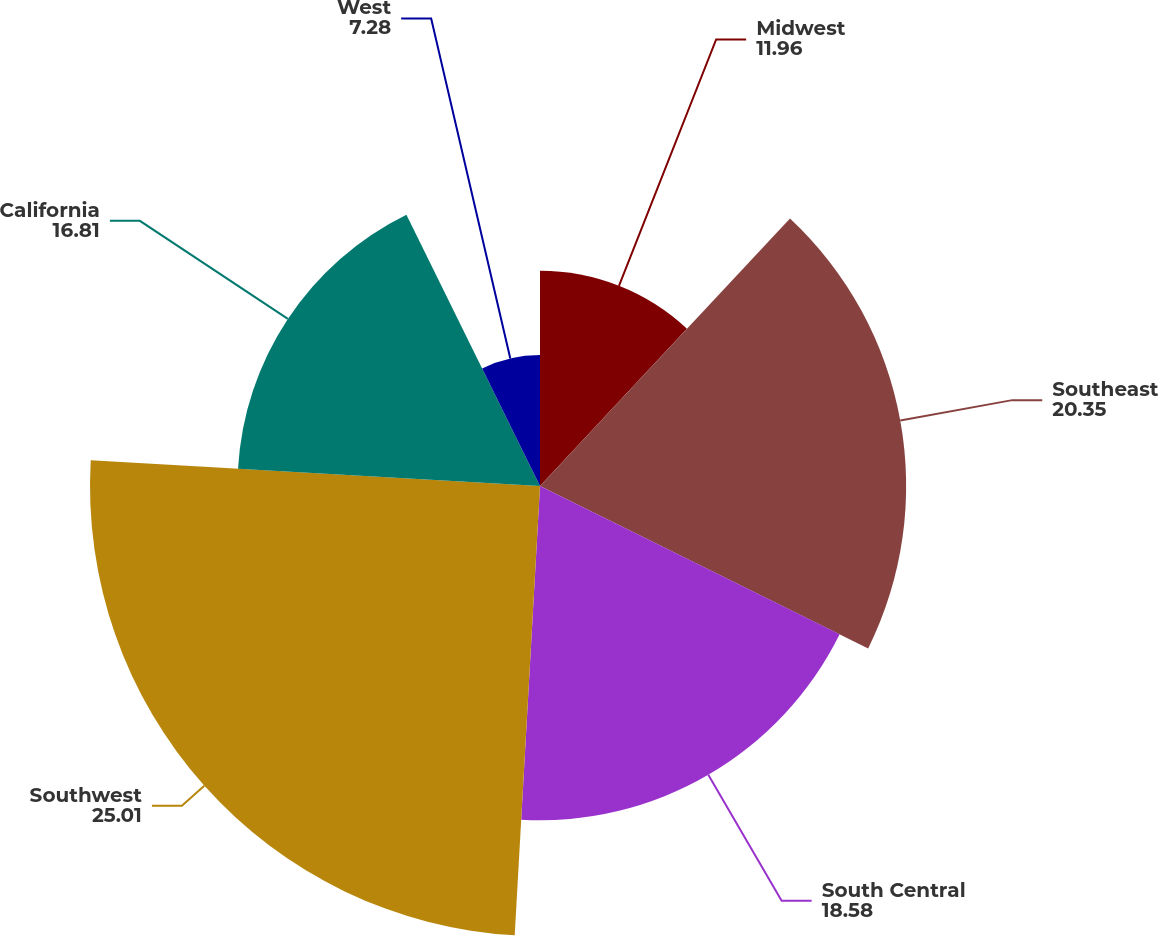Convert chart to OTSL. <chart><loc_0><loc_0><loc_500><loc_500><pie_chart><fcel>Midwest<fcel>Southeast<fcel>South Central<fcel>Southwest<fcel>California<fcel>West<nl><fcel>11.96%<fcel>20.35%<fcel>18.58%<fcel>25.01%<fcel>16.81%<fcel>7.28%<nl></chart> 